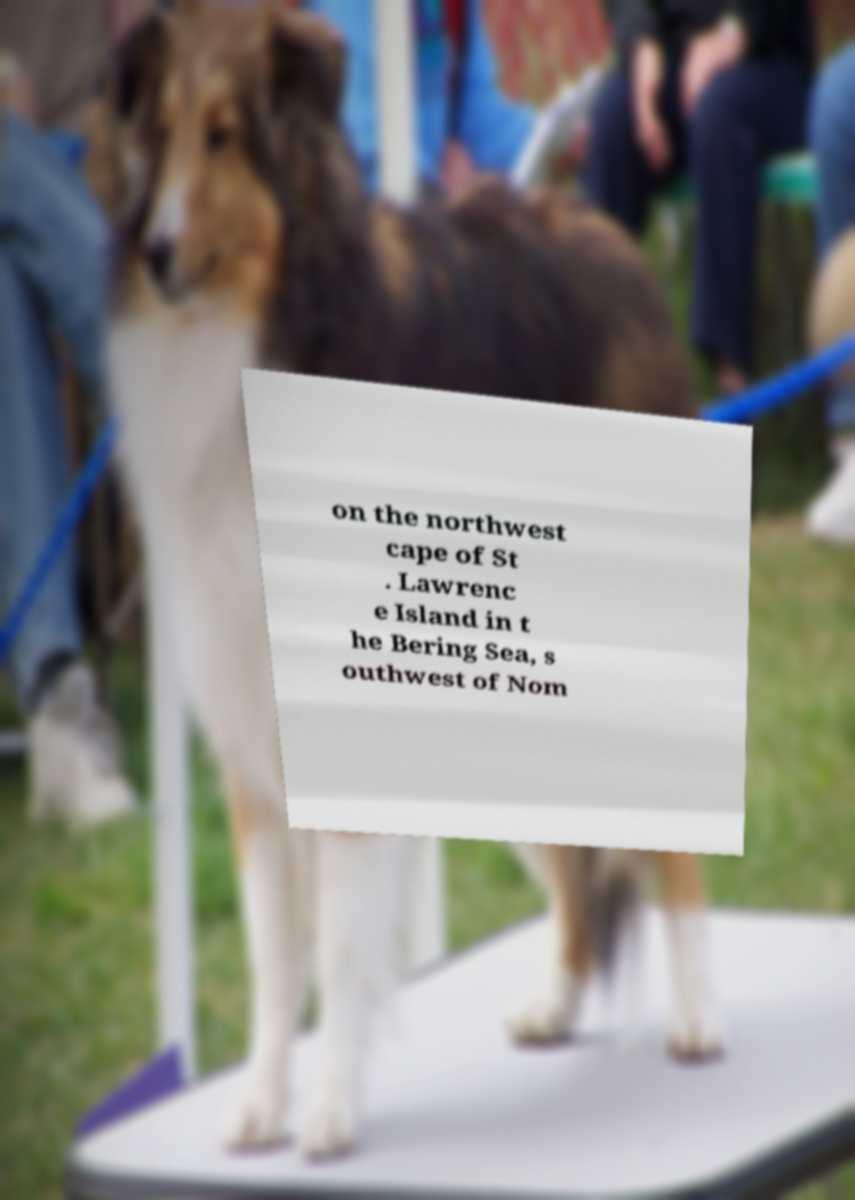Could you assist in decoding the text presented in this image and type it out clearly? on the northwest cape of St . Lawrenc e Island in t he Bering Sea, s outhwest of Nom 